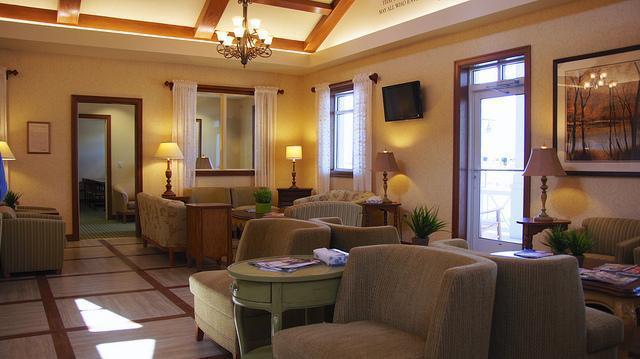How many lamps can you see?
Give a very brief answer. 5. How many couches are in the photo?
Give a very brief answer. 3. How many chairs are there?
Give a very brief answer. 5. 